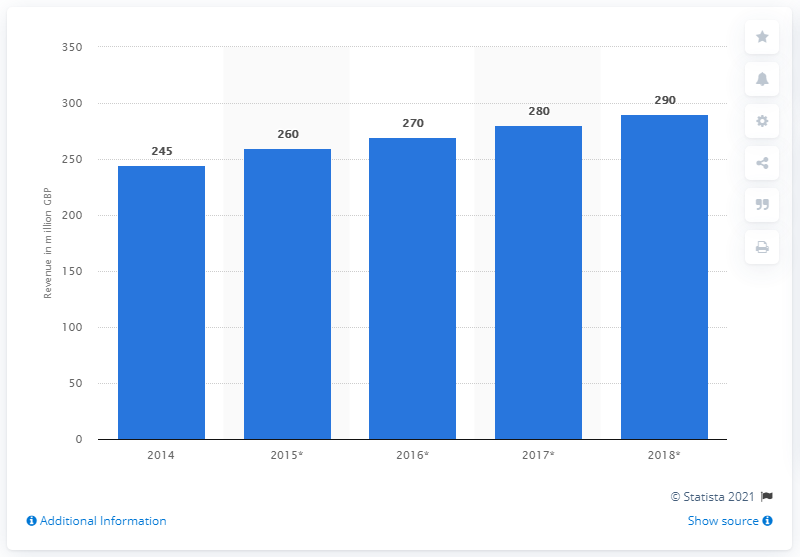Can you describe the trend in revenue from 2014 to 2018? From 2014 to 2018, there is a consistent upward trend in revenue. Starting at 245 million GBP in 2014, there's a noticeable increment each year, concluding with 290 million GBP in 2018. 